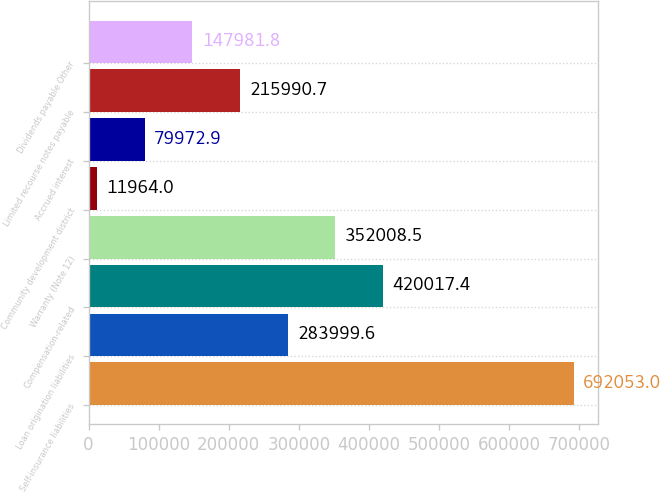<chart> <loc_0><loc_0><loc_500><loc_500><bar_chart><fcel>Self-insurance liabilities<fcel>Loan origination liabilities<fcel>Compensation-related<fcel>Warranty (Note 12)<fcel>Community development district<fcel>Accrued interest<fcel>Limited recourse notes payable<fcel>Dividends payable Other<nl><fcel>692053<fcel>284000<fcel>420017<fcel>352008<fcel>11964<fcel>79972.9<fcel>215991<fcel>147982<nl></chart> 